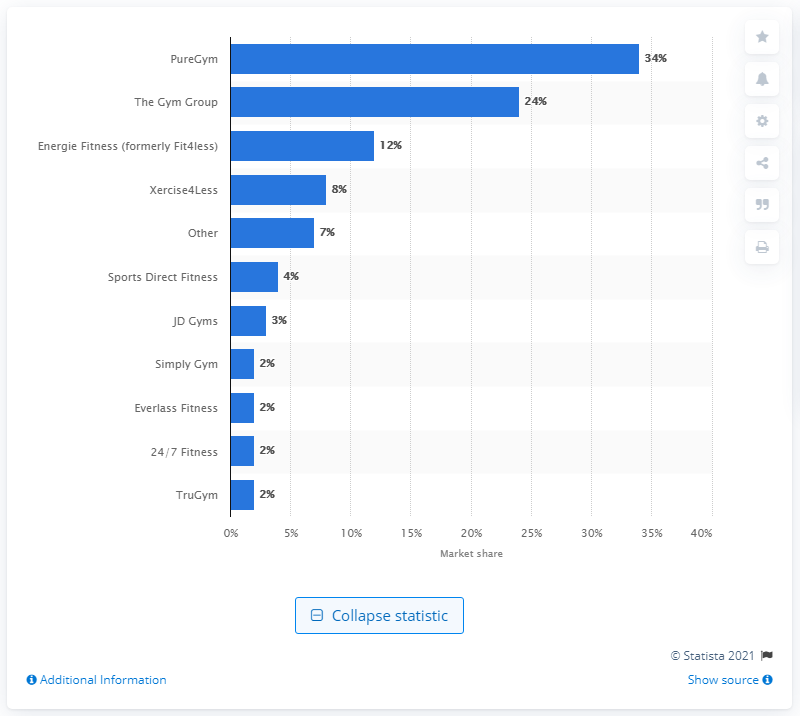List a handful of essential elements in this visual. According to our analysis, Pure Gym Limited has approximately 34% of the market segment. 